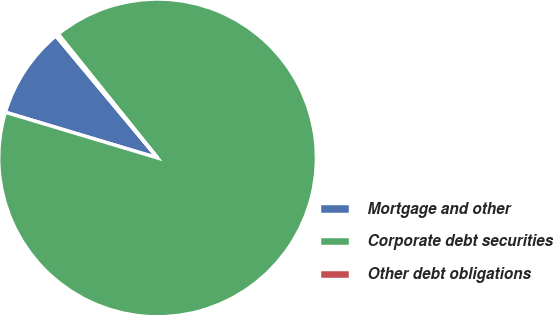Convert chart. <chart><loc_0><loc_0><loc_500><loc_500><pie_chart><fcel>Mortgage and other<fcel>Corporate debt securities<fcel>Other debt obligations<nl><fcel>9.3%<fcel>90.41%<fcel>0.29%<nl></chart> 